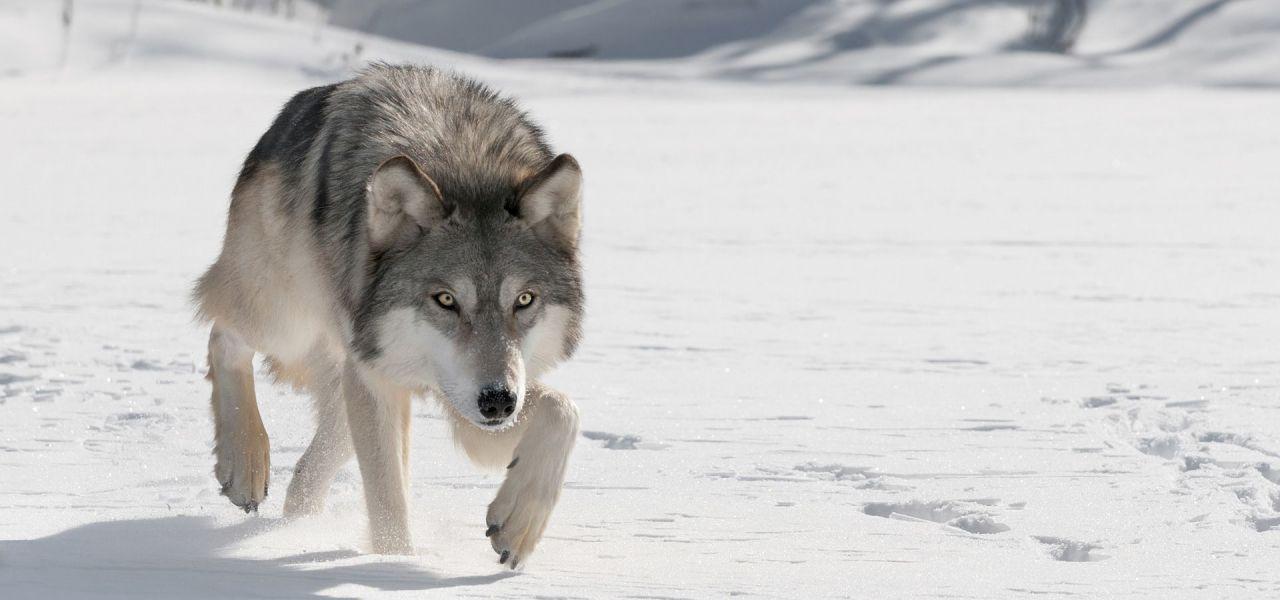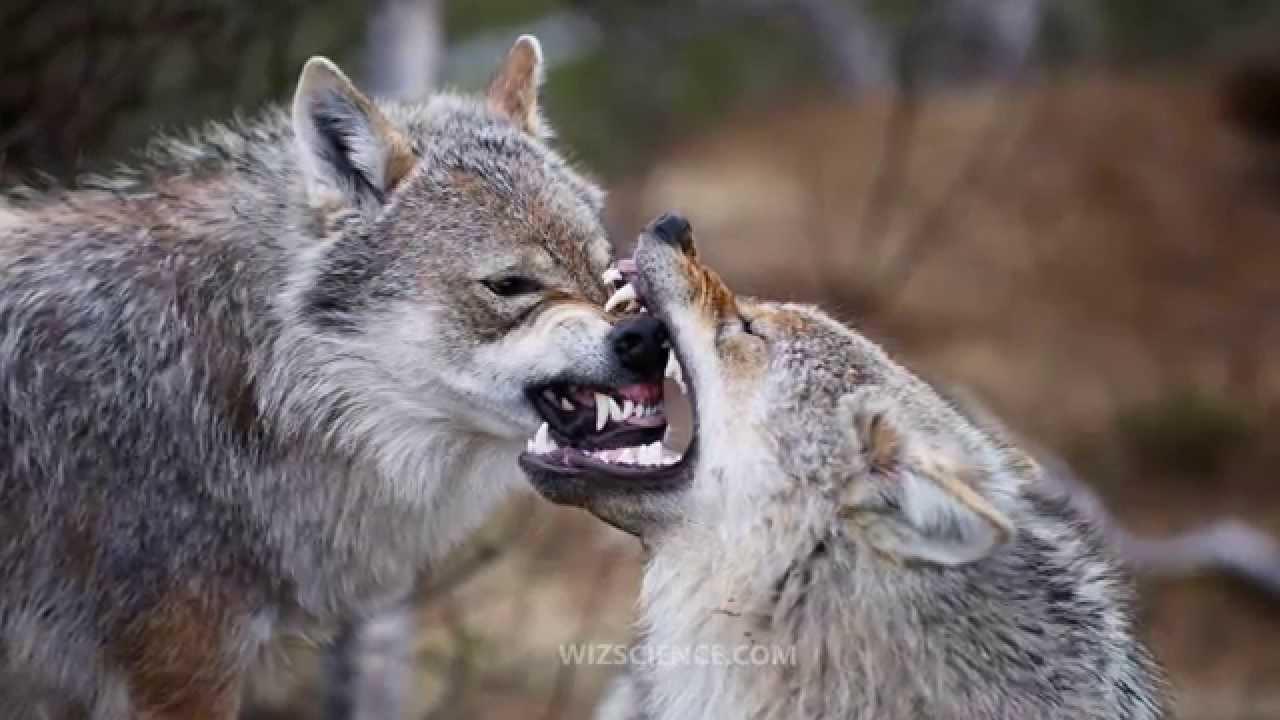The first image is the image on the left, the second image is the image on the right. Examine the images to the left and right. Is the description "The right image contains at least two wolves." accurate? Answer yes or no. Yes. 